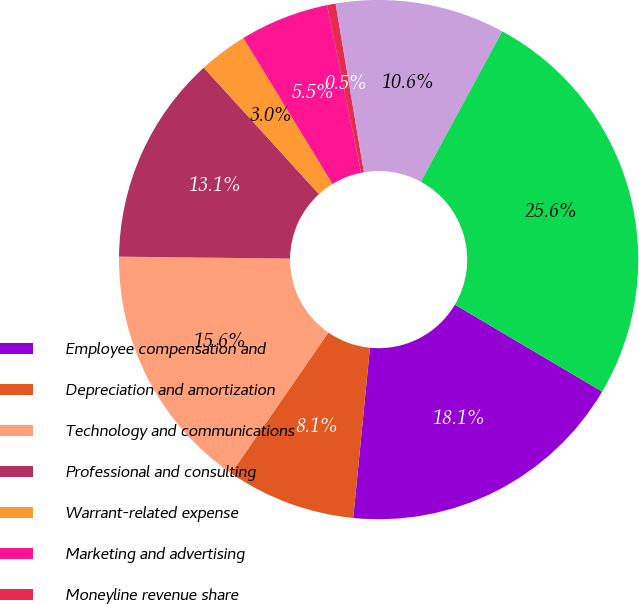Convert chart. <chart><loc_0><loc_0><loc_500><loc_500><pie_chart><fcel>Employee compensation and<fcel>Depreciation and amortization<fcel>Technology and communications<fcel>Professional and consulting<fcel>Warrant-related expense<fcel>Marketing and advertising<fcel>Moneyline revenue share<fcel>General and administrative<fcel>Total expenses<nl><fcel>18.07%<fcel>8.05%<fcel>15.57%<fcel>13.06%<fcel>3.04%<fcel>5.54%<fcel>0.53%<fcel>10.55%<fcel>25.59%<nl></chart> 